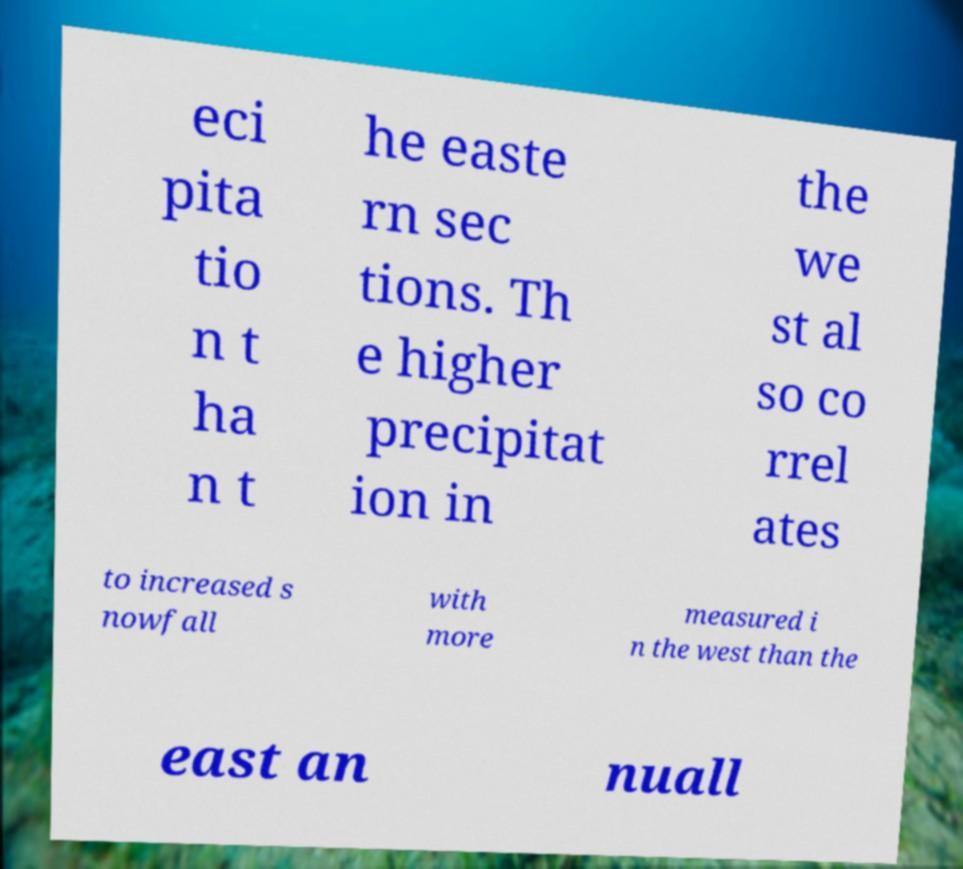Please identify and transcribe the text found in this image. eci pita tio n t ha n t he easte rn sec tions. Th e higher precipitat ion in the we st al so co rrel ates to increased s nowfall with more measured i n the west than the east an nuall 